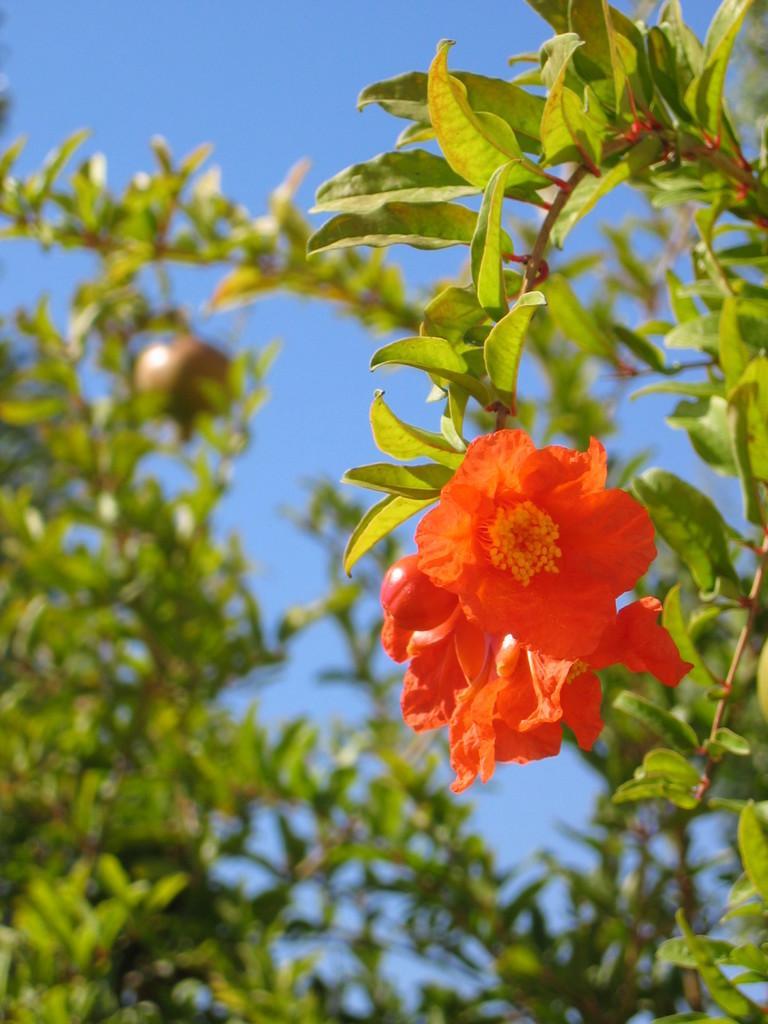In one or two sentences, can you explain what this image depicts? In the foreground of this image, there are flowers and it seems like it is a pomegranate tree and in the background, there is the sky. 